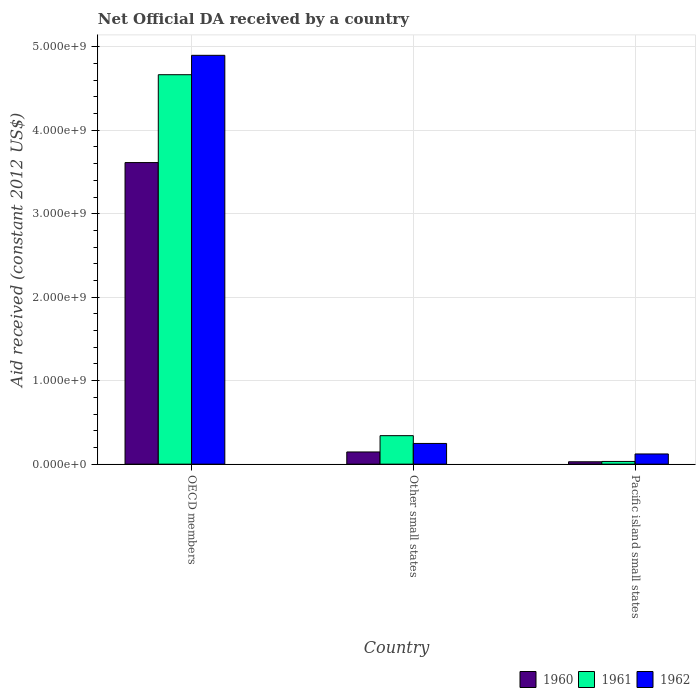How many different coloured bars are there?
Give a very brief answer. 3. Are the number of bars per tick equal to the number of legend labels?
Your response must be concise. Yes. How many bars are there on the 1st tick from the left?
Your answer should be compact. 3. How many bars are there on the 1st tick from the right?
Give a very brief answer. 3. In how many cases, is the number of bars for a given country not equal to the number of legend labels?
Offer a very short reply. 0. What is the net official development assistance aid received in 1960 in OECD members?
Give a very brief answer. 3.61e+09. Across all countries, what is the maximum net official development assistance aid received in 1960?
Provide a succinct answer. 3.61e+09. Across all countries, what is the minimum net official development assistance aid received in 1962?
Your response must be concise. 1.22e+08. In which country was the net official development assistance aid received in 1960 minimum?
Your response must be concise. Pacific island small states. What is the total net official development assistance aid received in 1962 in the graph?
Offer a terse response. 5.27e+09. What is the difference between the net official development assistance aid received in 1961 in Other small states and that in Pacific island small states?
Your answer should be compact. 3.09e+08. What is the difference between the net official development assistance aid received in 1961 in Other small states and the net official development assistance aid received in 1960 in OECD members?
Offer a terse response. -3.27e+09. What is the average net official development assistance aid received in 1961 per country?
Offer a terse response. 1.68e+09. What is the difference between the net official development assistance aid received of/in 1961 and net official development assistance aid received of/in 1962 in OECD members?
Provide a short and direct response. -2.32e+08. In how many countries, is the net official development assistance aid received in 1962 greater than 3800000000 US$?
Provide a short and direct response. 1. What is the ratio of the net official development assistance aid received in 1961 in OECD members to that in Pacific island small states?
Offer a terse response. 143.69. Is the net official development assistance aid received in 1962 in Other small states less than that in Pacific island small states?
Ensure brevity in your answer.  No. Is the difference between the net official development assistance aid received in 1961 in Other small states and Pacific island small states greater than the difference between the net official development assistance aid received in 1962 in Other small states and Pacific island small states?
Offer a very short reply. Yes. What is the difference between the highest and the second highest net official development assistance aid received in 1962?
Keep it short and to the point. 4.78e+09. What is the difference between the highest and the lowest net official development assistance aid received in 1962?
Keep it short and to the point. 4.78e+09. In how many countries, is the net official development assistance aid received in 1962 greater than the average net official development assistance aid received in 1962 taken over all countries?
Offer a very short reply. 1. What does the 3rd bar from the left in Other small states represents?
Your answer should be very brief. 1962. Is it the case that in every country, the sum of the net official development assistance aid received in 1961 and net official development assistance aid received in 1962 is greater than the net official development assistance aid received in 1960?
Your response must be concise. Yes. How many bars are there?
Give a very brief answer. 9. Are all the bars in the graph horizontal?
Offer a very short reply. No. How many countries are there in the graph?
Your response must be concise. 3. What is the difference between two consecutive major ticks on the Y-axis?
Ensure brevity in your answer.  1.00e+09. Does the graph contain any zero values?
Provide a short and direct response. No. Does the graph contain grids?
Offer a terse response. Yes. Where does the legend appear in the graph?
Provide a short and direct response. Bottom right. What is the title of the graph?
Offer a very short reply. Net Official DA received by a country. What is the label or title of the Y-axis?
Offer a terse response. Aid received (constant 2012 US$). What is the Aid received (constant 2012 US$) in 1960 in OECD members?
Offer a very short reply. 3.61e+09. What is the Aid received (constant 2012 US$) of 1961 in OECD members?
Provide a succinct answer. 4.67e+09. What is the Aid received (constant 2012 US$) in 1962 in OECD members?
Keep it short and to the point. 4.90e+09. What is the Aid received (constant 2012 US$) of 1960 in Other small states?
Provide a short and direct response. 1.46e+08. What is the Aid received (constant 2012 US$) in 1961 in Other small states?
Make the answer very short. 3.41e+08. What is the Aid received (constant 2012 US$) of 1962 in Other small states?
Offer a very short reply. 2.48e+08. What is the Aid received (constant 2012 US$) of 1960 in Pacific island small states?
Offer a terse response. 2.87e+07. What is the Aid received (constant 2012 US$) in 1961 in Pacific island small states?
Provide a succinct answer. 3.25e+07. What is the Aid received (constant 2012 US$) in 1962 in Pacific island small states?
Offer a very short reply. 1.22e+08. Across all countries, what is the maximum Aid received (constant 2012 US$) in 1960?
Offer a terse response. 3.61e+09. Across all countries, what is the maximum Aid received (constant 2012 US$) of 1961?
Offer a terse response. 4.67e+09. Across all countries, what is the maximum Aid received (constant 2012 US$) in 1962?
Make the answer very short. 4.90e+09. Across all countries, what is the minimum Aid received (constant 2012 US$) in 1960?
Make the answer very short. 2.87e+07. Across all countries, what is the minimum Aid received (constant 2012 US$) of 1961?
Provide a short and direct response. 3.25e+07. Across all countries, what is the minimum Aid received (constant 2012 US$) of 1962?
Give a very brief answer. 1.22e+08. What is the total Aid received (constant 2012 US$) of 1960 in the graph?
Keep it short and to the point. 3.79e+09. What is the total Aid received (constant 2012 US$) of 1961 in the graph?
Keep it short and to the point. 5.04e+09. What is the total Aid received (constant 2012 US$) in 1962 in the graph?
Your answer should be very brief. 5.27e+09. What is the difference between the Aid received (constant 2012 US$) in 1960 in OECD members and that in Other small states?
Provide a short and direct response. 3.47e+09. What is the difference between the Aid received (constant 2012 US$) in 1961 in OECD members and that in Other small states?
Your answer should be compact. 4.32e+09. What is the difference between the Aid received (constant 2012 US$) in 1962 in OECD members and that in Other small states?
Ensure brevity in your answer.  4.65e+09. What is the difference between the Aid received (constant 2012 US$) in 1960 in OECD members and that in Pacific island small states?
Keep it short and to the point. 3.58e+09. What is the difference between the Aid received (constant 2012 US$) in 1961 in OECD members and that in Pacific island small states?
Keep it short and to the point. 4.63e+09. What is the difference between the Aid received (constant 2012 US$) in 1962 in OECD members and that in Pacific island small states?
Provide a short and direct response. 4.78e+09. What is the difference between the Aid received (constant 2012 US$) of 1960 in Other small states and that in Pacific island small states?
Your answer should be very brief. 1.17e+08. What is the difference between the Aid received (constant 2012 US$) of 1961 in Other small states and that in Pacific island small states?
Your response must be concise. 3.09e+08. What is the difference between the Aid received (constant 2012 US$) in 1962 in Other small states and that in Pacific island small states?
Your answer should be compact. 1.26e+08. What is the difference between the Aid received (constant 2012 US$) of 1960 in OECD members and the Aid received (constant 2012 US$) of 1961 in Other small states?
Make the answer very short. 3.27e+09. What is the difference between the Aid received (constant 2012 US$) in 1960 in OECD members and the Aid received (constant 2012 US$) in 1962 in Other small states?
Provide a short and direct response. 3.36e+09. What is the difference between the Aid received (constant 2012 US$) in 1961 in OECD members and the Aid received (constant 2012 US$) in 1962 in Other small states?
Provide a short and direct response. 4.42e+09. What is the difference between the Aid received (constant 2012 US$) of 1960 in OECD members and the Aid received (constant 2012 US$) of 1961 in Pacific island small states?
Give a very brief answer. 3.58e+09. What is the difference between the Aid received (constant 2012 US$) of 1960 in OECD members and the Aid received (constant 2012 US$) of 1962 in Pacific island small states?
Offer a very short reply. 3.49e+09. What is the difference between the Aid received (constant 2012 US$) of 1961 in OECD members and the Aid received (constant 2012 US$) of 1962 in Pacific island small states?
Your answer should be compact. 4.54e+09. What is the difference between the Aid received (constant 2012 US$) of 1960 in Other small states and the Aid received (constant 2012 US$) of 1961 in Pacific island small states?
Provide a succinct answer. 1.14e+08. What is the difference between the Aid received (constant 2012 US$) in 1960 in Other small states and the Aid received (constant 2012 US$) in 1962 in Pacific island small states?
Make the answer very short. 2.39e+07. What is the difference between the Aid received (constant 2012 US$) of 1961 in Other small states and the Aid received (constant 2012 US$) of 1962 in Pacific island small states?
Ensure brevity in your answer.  2.19e+08. What is the average Aid received (constant 2012 US$) in 1960 per country?
Offer a very short reply. 1.26e+09. What is the average Aid received (constant 2012 US$) in 1961 per country?
Offer a terse response. 1.68e+09. What is the average Aid received (constant 2012 US$) in 1962 per country?
Make the answer very short. 1.76e+09. What is the difference between the Aid received (constant 2012 US$) of 1960 and Aid received (constant 2012 US$) of 1961 in OECD members?
Your answer should be very brief. -1.05e+09. What is the difference between the Aid received (constant 2012 US$) in 1960 and Aid received (constant 2012 US$) in 1962 in OECD members?
Provide a short and direct response. -1.28e+09. What is the difference between the Aid received (constant 2012 US$) in 1961 and Aid received (constant 2012 US$) in 1962 in OECD members?
Ensure brevity in your answer.  -2.32e+08. What is the difference between the Aid received (constant 2012 US$) in 1960 and Aid received (constant 2012 US$) in 1961 in Other small states?
Give a very brief answer. -1.95e+08. What is the difference between the Aid received (constant 2012 US$) in 1960 and Aid received (constant 2012 US$) in 1962 in Other small states?
Offer a terse response. -1.02e+08. What is the difference between the Aid received (constant 2012 US$) of 1961 and Aid received (constant 2012 US$) of 1962 in Other small states?
Offer a terse response. 9.32e+07. What is the difference between the Aid received (constant 2012 US$) of 1960 and Aid received (constant 2012 US$) of 1961 in Pacific island small states?
Provide a succinct answer. -3.76e+06. What is the difference between the Aid received (constant 2012 US$) of 1960 and Aid received (constant 2012 US$) of 1962 in Pacific island small states?
Your answer should be very brief. -9.36e+07. What is the difference between the Aid received (constant 2012 US$) in 1961 and Aid received (constant 2012 US$) in 1962 in Pacific island small states?
Your answer should be very brief. -8.98e+07. What is the ratio of the Aid received (constant 2012 US$) in 1960 in OECD members to that in Other small states?
Provide a succinct answer. 24.72. What is the ratio of the Aid received (constant 2012 US$) of 1961 in OECD members to that in Other small states?
Give a very brief answer. 13.66. What is the ratio of the Aid received (constant 2012 US$) in 1962 in OECD members to that in Other small states?
Ensure brevity in your answer.  19.73. What is the ratio of the Aid received (constant 2012 US$) of 1960 in OECD members to that in Pacific island small states?
Provide a succinct answer. 125.84. What is the ratio of the Aid received (constant 2012 US$) in 1961 in OECD members to that in Pacific island small states?
Your answer should be compact. 143.69. What is the ratio of the Aid received (constant 2012 US$) of 1962 in OECD members to that in Pacific island small states?
Your answer should be compact. 40.06. What is the ratio of the Aid received (constant 2012 US$) of 1960 in Other small states to that in Pacific island small states?
Your response must be concise. 5.09. What is the ratio of the Aid received (constant 2012 US$) in 1961 in Other small states to that in Pacific island small states?
Your answer should be very brief. 10.52. What is the ratio of the Aid received (constant 2012 US$) in 1962 in Other small states to that in Pacific island small states?
Provide a succinct answer. 2.03. What is the difference between the highest and the second highest Aid received (constant 2012 US$) in 1960?
Ensure brevity in your answer.  3.47e+09. What is the difference between the highest and the second highest Aid received (constant 2012 US$) in 1961?
Ensure brevity in your answer.  4.32e+09. What is the difference between the highest and the second highest Aid received (constant 2012 US$) in 1962?
Give a very brief answer. 4.65e+09. What is the difference between the highest and the lowest Aid received (constant 2012 US$) of 1960?
Offer a very short reply. 3.58e+09. What is the difference between the highest and the lowest Aid received (constant 2012 US$) in 1961?
Offer a very short reply. 4.63e+09. What is the difference between the highest and the lowest Aid received (constant 2012 US$) in 1962?
Provide a short and direct response. 4.78e+09. 